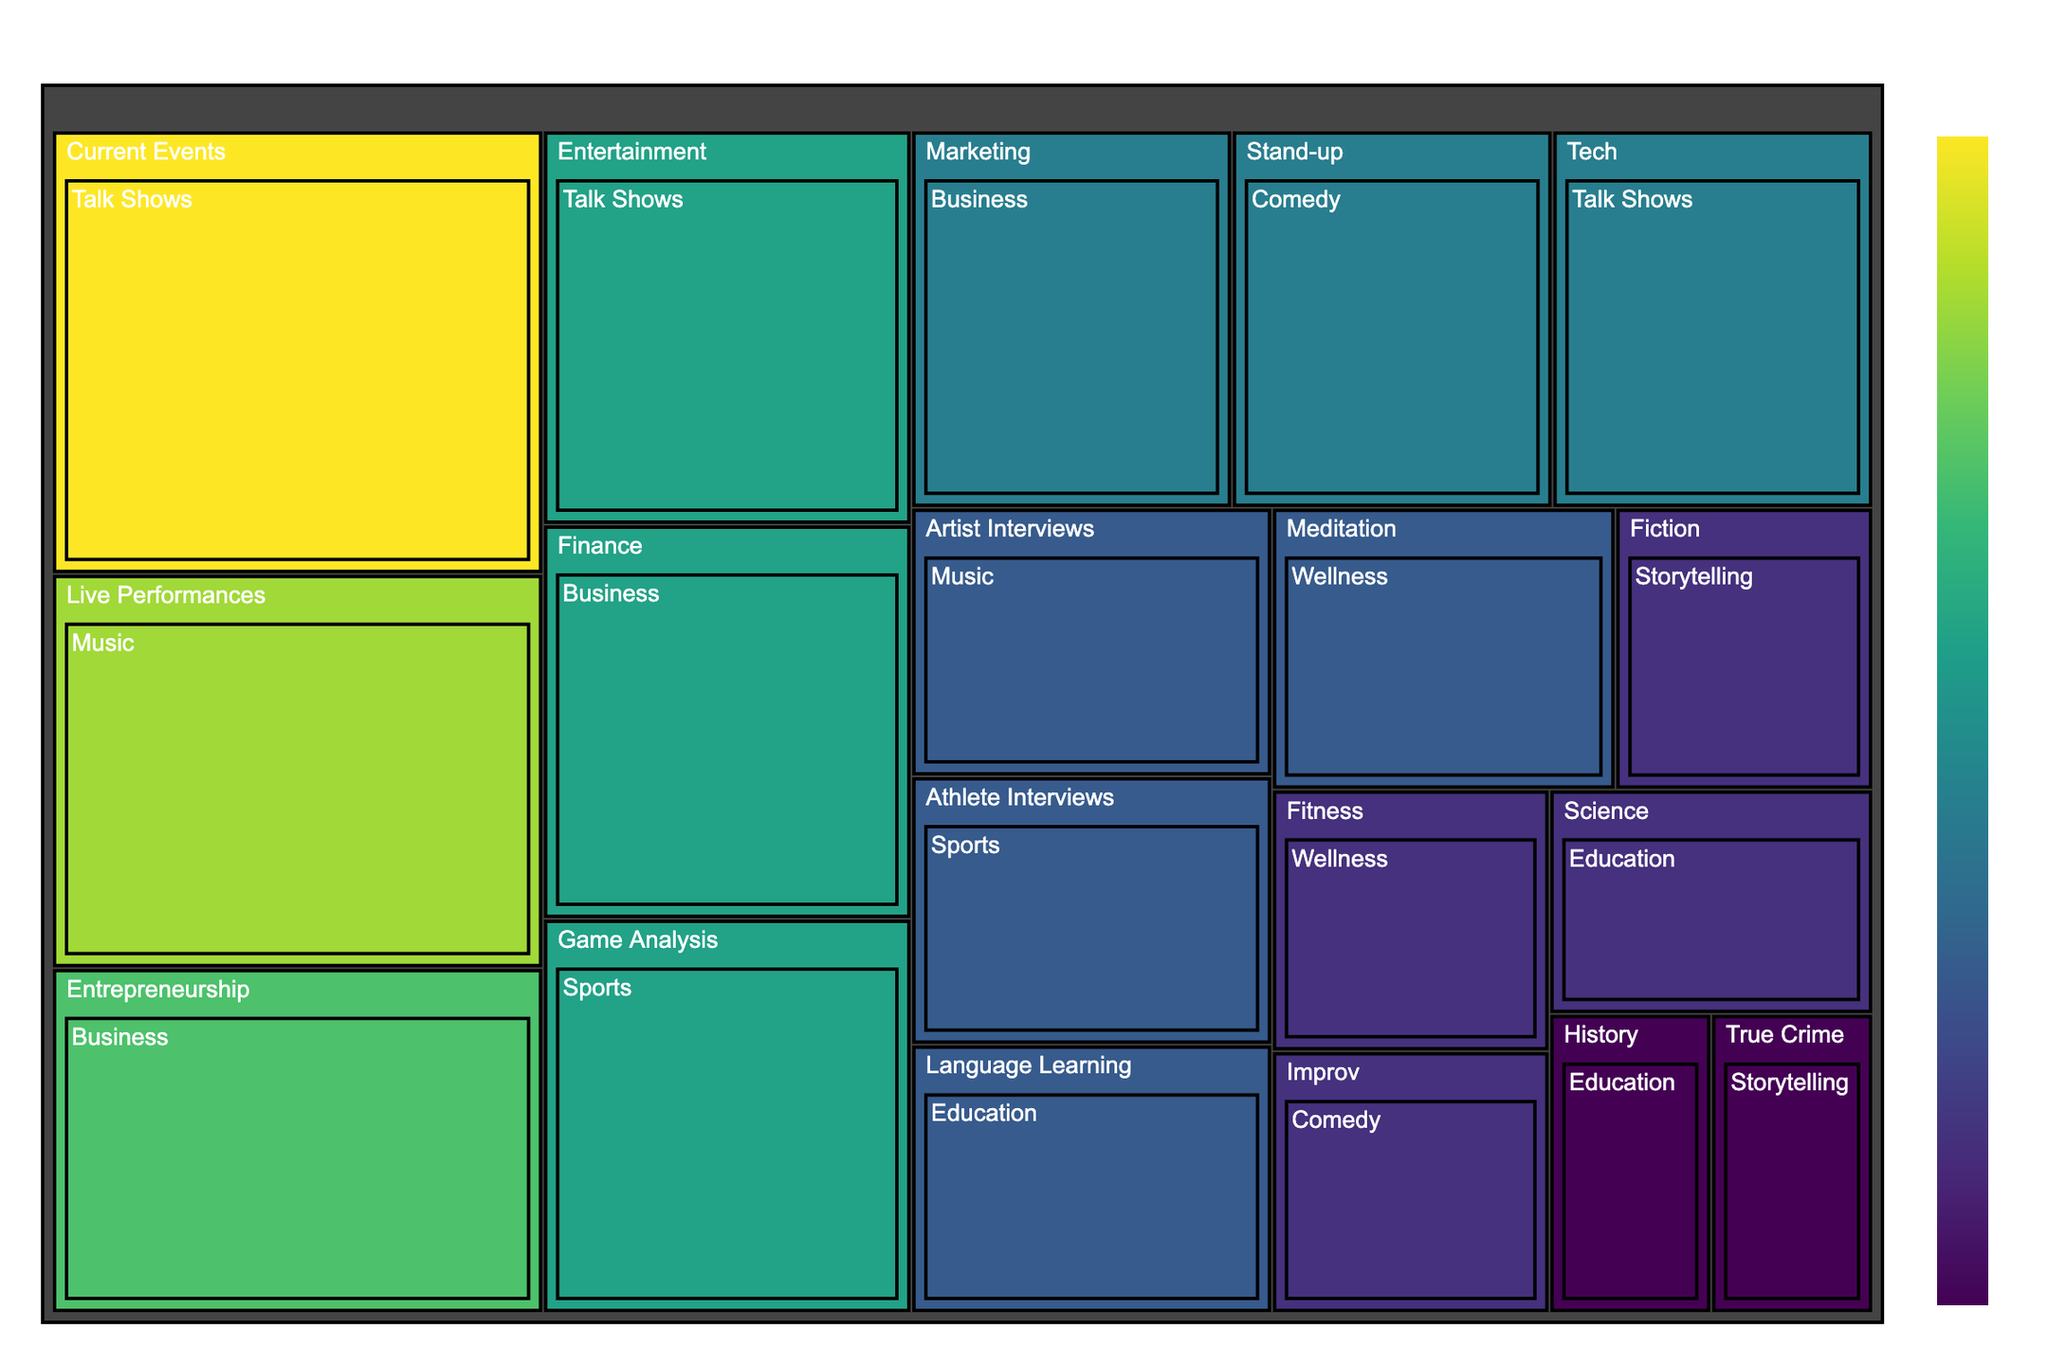What is the title of the treemap? The title of the figure is typically found at the top and serves to explain the main subject of the visualization, which in this case is "Audio Content Consumption Habits of Clubhouse Users".
Answer: Audio Content Consumption Habits of Clubhouse Users Which genre has more hours in the Comedy category? The Comedy category includes two genres: Stand-up with 25 hours and Improv with 15 hours. By comparing the hours, Stand-up has more hours than Improv.
Answer: Stand-up How many total hours are there in the Business category? The Business category includes three genres: Entrepreneurship with 35 hours, Finance with 30 hours, and Marketing with 25 hours. Summing them up, 35 + 30 + 25 = 90 hours.
Answer: 90 hours What is the least consumed genre in the Storytelling category? The Storytelling category includes two genres: Fiction with 15 hours and True Crime with 10 hours. By comparing the hours, True Crime is the least consumed genre.
Answer: True Crime Which category has the highest total number of hours? To find the category with the highest total number of hours, compare the sums of hours for each category using the visual blocks' sizes and values. By calculation, Talk Shows (45 + 30 + 25 = 100 hours) has the highest total.
Answer: Talk Shows Compare the hours of Music's Live Performances to Music's Artist Interviews. Which has more? Within the Music category, Live Performances has 40 hours and Artist Interviews has 20 hours. Live Performances has more hours than Artist Interviews.
Answer: Live Performances What is the combined total of hours for genres under the Education category? The Education category includes three genres: Language Learning with 20 hours, Science with 15 hours, and History with 10 hours. Adding them together, 20 + 15 + 10 = 45 hours.
Answer: 45 hours Between the categories of Wellness and Sports, which contains more hours in total? Wellness includes Meditation with 20 hours and Fitness with 15 hours, totaling 35 hours. Sports includes Game Analysis with 30 hours and Athlete Interviews with 20 hours, totaling 50 hours. Since 50 hours is greater than 35 hours, Sports has more hours.
Answer: Sports Which genre has the least number of hours across all categories? Identify the smallest block or the lower bound numeric value in the treemap, which shows that History within the Education category and True Crime within the Storytelling category both have the least number of hours at 10 each.
Answer: History and True Crime What is the total number of categories in the treemap? By counting the unique parent blocks or main category nodes, there are seven categories: Talk Shows, Music, Business, Education, Storytelling, Wellness, and Comedy.
Answer: 7 categories 